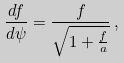Convert formula to latex. <formula><loc_0><loc_0><loc_500><loc_500>\frac { d f } { d \psi } = \frac { f } { \sqrt { 1 + \frac { f } { a } } } \, ,</formula> 